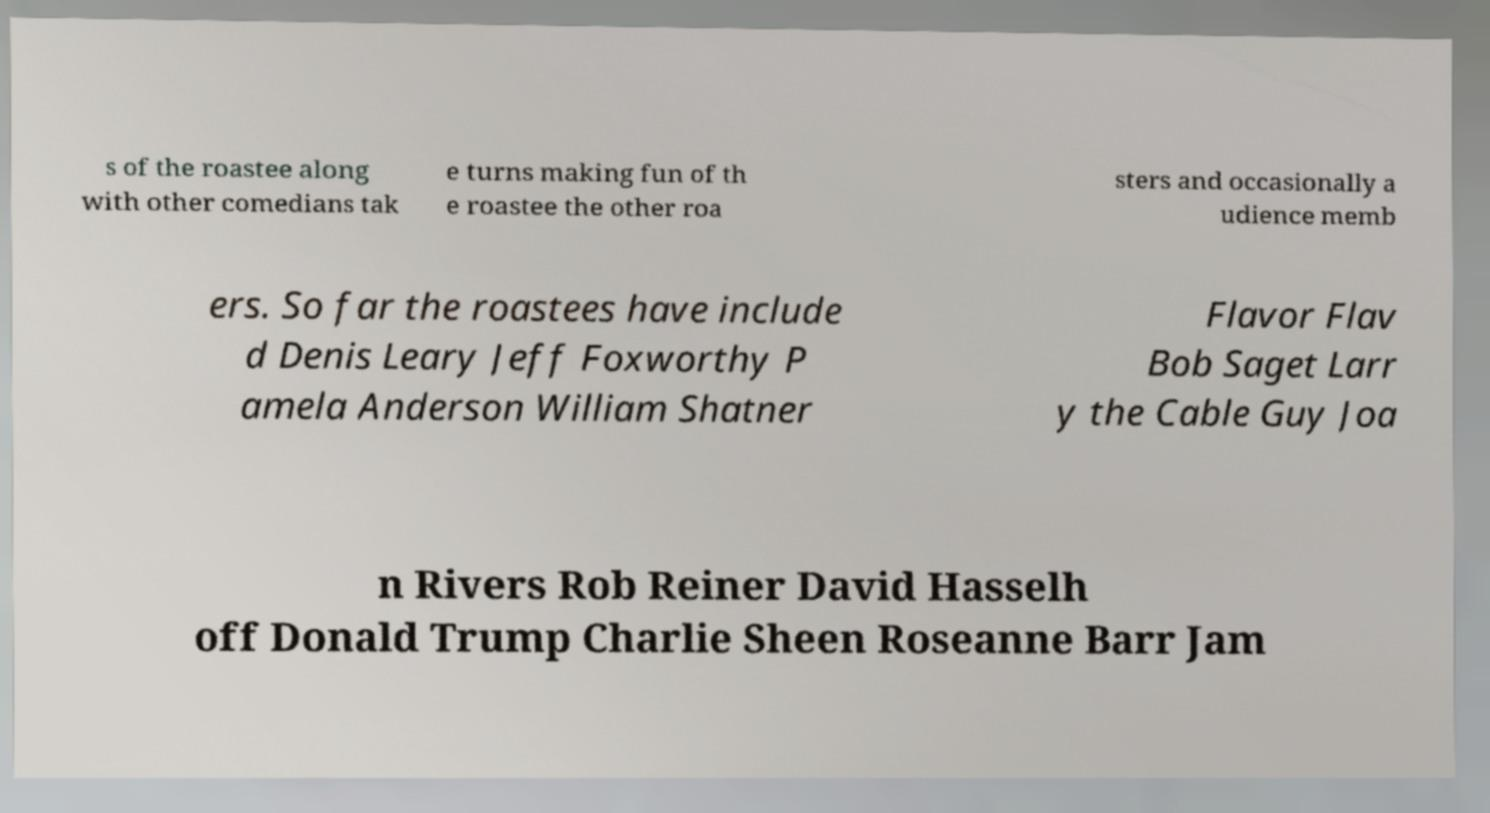Please read and relay the text visible in this image. What does it say? s of the roastee along with other comedians tak e turns making fun of th e roastee the other roa sters and occasionally a udience memb ers. So far the roastees have include d Denis Leary Jeff Foxworthy P amela Anderson William Shatner Flavor Flav Bob Saget Larr y the Cable Guy Joa n Rivers Rob Reiner David Hasselh off Donald Trump Charlie Sheen Roseanne Barr Jam 